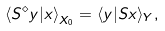<formula> <loc_0><loc_0><loc_500><loc_500>\left \langle S ^ { \diamond } y | x \right \rangle _ { X _ { 0 } } = \langle y | S x \rangle _ { Y } ,</formula> 